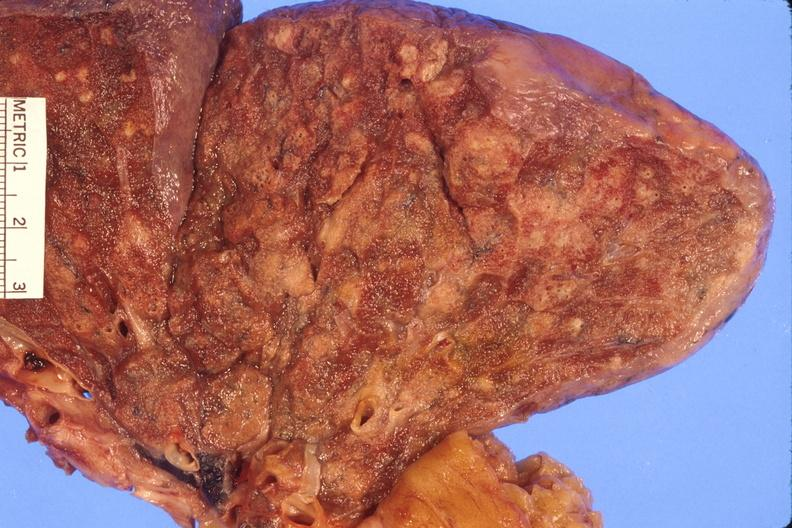what is present?
Answer the question using a single word or phrase. Respiratory 